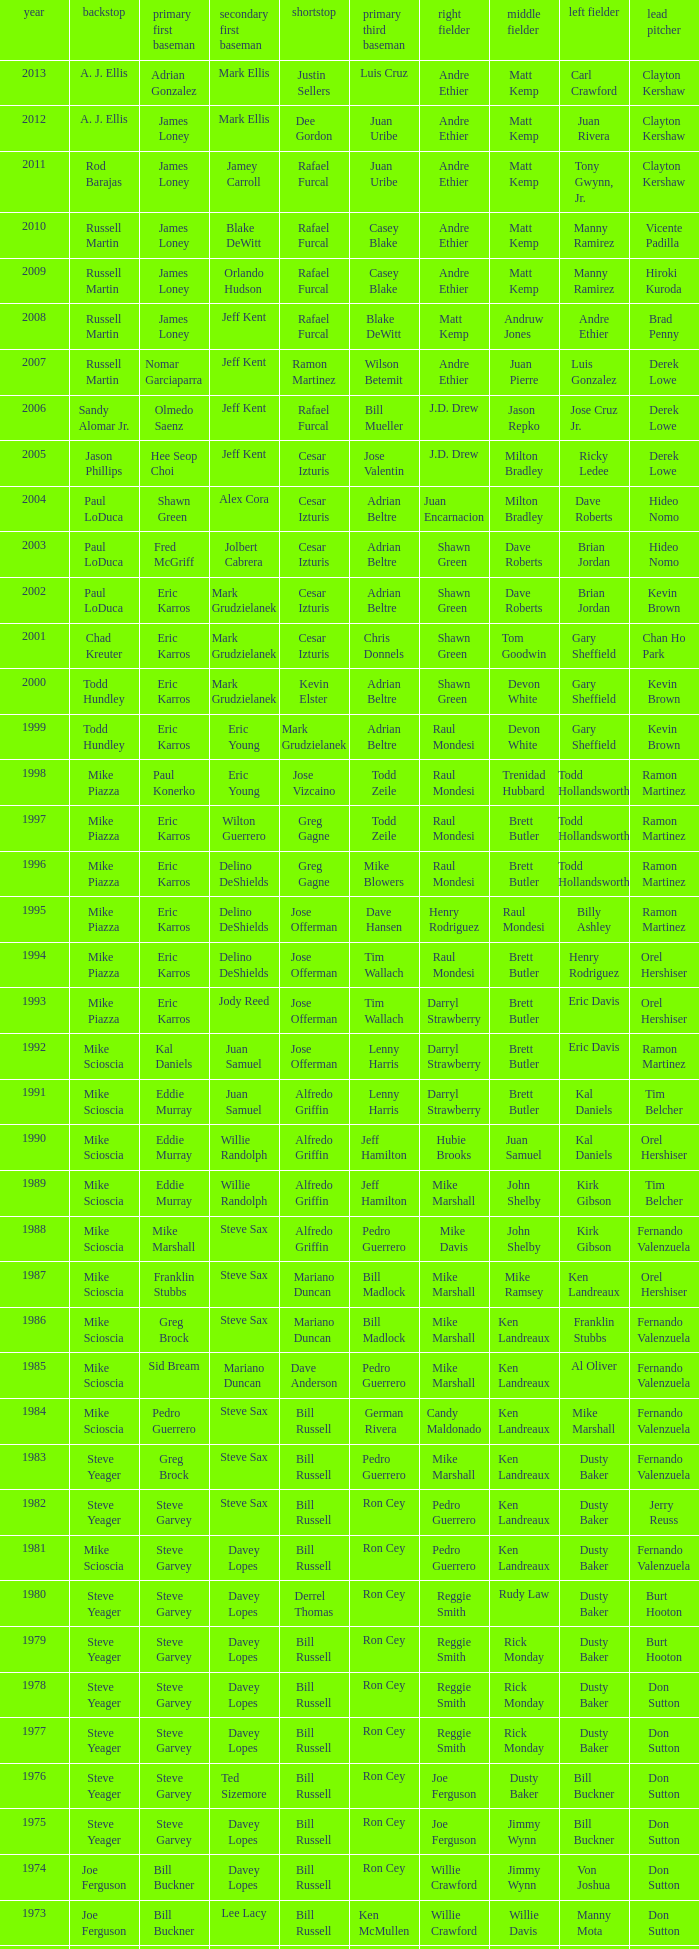Who played SS when paul konerko played 1st base? Jose Vizcaino. Can you parse all the data within this table? {'header': ['year', 'backstop', 'primary first baseman', 'secondary first baseman', 'shortstop', 'primary third baseman', 'right fielder', 'middle fielder', 'left fielder', 'lead pitcher'], 'rows': [['2013', 'A. J. Ellis', 'Adrian Gonzalez', 'Mark Ellis', 'Justin Sellers', 'Luis Cruz', 'Andre Ethier', 'Matt Kemp', 'Carl Crawford', 'Clayton Kershaw'], ['2012', 'A. J. Ellis', 'James Loney', 'Mark Ellis', 'Dee Gordon', 'Juan Uribe', 'Andre Ethier', 'Matt Kemp', 'Juan Rivera', 'Clayton Kershaw'], ['2011', 'Rod Barajas', 'James Loney', 'Jamey Carroll', 'Rafael Furcal', 'Juan Uribe', 'Andre Ethier', 'Matt Kemp', 'Tony Gwynn, Jr.', 'Clayton Kershaw'], ['2010', 'Russell Martin', 'James Loney', 'Blake DeWitt', 'Rafael Furcal', 'Casey Blake', 'Andre Ethier', 'Matt Kemp', 'Manny Ramirez', 'Vicente Padilla'], ['2009', 'Russell Martin', 'James Loney', 'Orlando Hudson', 'Rafael Furcal', 'Casey Blake', 'Andre Ethier', 'Matt Kemp', 'Manny Ramirez', 'Hiroki Kuroda'], ['2008', 'Russell Martin', 'James Loney', 'Jeff Kent', 'Rafael Furcal', 'Blake DeWitt', 'Matt Kemp', 'Andruw Jones', 'Andre Ethier', 'Brad Penny'], ['2007', 'Russell Martin', 'Nomar Garciaparra', 'Jeff Kent', 'Ramon Martinez', 'Wilson Betemit', 'Andre Ethier', 'Juan Pierre', 'Luis Gonzalez', 'Derek Lowe'], ['2006', 'Sandy Alomar Jr.', 'Olmedo Saenz', 'Jeff Kent', 'Rafael Furcal', 'Bill Mueller', 'J.D. Drew', 'Jason Repko', 'Jose Cruz Jr.', 'Derek Lowe'], ['2005', 'Jason Phillips', 'Hee Seop Choi', 'Jeff Kent', 'Cesar Izturis', 'Jose Valentin', 'J.D. Drew', 'Milton Bradley', 'Ricky Ledee', 'Derek Lowe'], ['2004', 'Paul LoDuca', 'Shawn Green', 'Alex Cora', 'Cesar Izturis', 'Adrian Beltre', 'Juan Encarnacion', 'Milton Bradley', 'Dave Roberts', 'Hideo Nomo'], ['2003', 'Paul LoDuca', 'Fred McGriff', 'Jolbert Cabrera', 'Cesar Izturis', 'Adrian Beltre', 'Shawn Green', 'Dave Roberts', 'Brian Jordan', 'Hideo Nomo'], ['2002', 'Paul LoDuca', 'Eric Karros', 'Mark Grudzielanek', 'Cesar Izturis', 'Adrian Beltre', 'Shawn Green', 'Dave Roberts', 'Brian Jordan', 'Kevin Brown'], ['2001', 'Chad Kreuter', 'Eric Karros', 'Mark Grudzielanek', 'Cesar Izturis', 'Chris Donnels', 'Shawn Green', 'Tom Goodwin', 'Gary Sheffield', 'Chan Ho Park'], ['2000', 'Todd Hundley', 'Eric Karros', 'Mark Grudzielanek', 'Kevin Elster', 'Adrian Beltre', 'Shawn Green', 'Devon White', 'Gary Sheffield', 'Kevin Brown'], ['1999', 'Todd Hundley', 'Eric Karros', 'Eric Young', 'Mark Grudzielanek', 'Adrian Beltre', 'Raul Mondesi', 'Devon White', 'Gary Sheffield', 'Kevin Brown'], ['1998', 'Mike Piazza', 'Paul Konerko', 'Eric Young', 'Jose Vizcaino', 'Todd Zeile', 'Raul Mondesi', 'Trenidad Hubbard', 'Todd Hollandsworth', 'Ramon Martinez'], ['1997', 'Mike Piazza', 'Eric Karros', 'Wilton Guerrero', 'Greg Gagne', 'Todd Zeile', 'Raul Mondesi', 'Brett Butler', 'Todd Hollandsworth', 'Ramon Martinez'], ['1996', 'Mike Piazza', 'Eric Karros', 'Delino DeShields', 'Greg Gagne', 'Mike Blowers', 'Raul Mondesi', 'Brett Butler', 'Todd Hollandsworth', 'Ramon Martinez'], ['1995', 'Mike Piazza', 'Eric Karros', 'Delino DeShields', 'Jose Offerman', 'Dave Hansen', 'Henry Rodriguez', 'Raul Mondesi', 'Billy Ashley', 'Ramon Martinez'], ['1994', 'Mike Piazza', 'Eric Karros', 'Delino DeShields', 'Jose Offerman', 'Tim Wallach', 'Raul Mondesi', 'Brett Butler', 'Henry Rodriguez', 'Orel Hershiser'], ['1993', 'Mike Piazza', 'Eric Karros', 'Jody Reed', 'Jose Offerman', 'Tim Wallach', 'Darryl Strawberry', 'Brett Butler', 'Eric Davis', 'Orel Hershiser'], ['1992', 'Mike Scioscia', 'Kal Daniels', 'Juan Samuel', 'Jose Offerman', 'Lenny Harris', 'Darryl Strawberry', 'Brett Butler', 'Eric Davis', 'Ramon Martinez'], ['1991', 'Mike Scioscia', 'Eddie Murray', 'Juan Samuel', 'Alfredo Griffin', 'Lenny Harris', 'Darryl Strawberry', 'Brett Butler', 'Kal Daniels', 'Tim Belcher'], ['1990', 'Mike Scioscia', 'Eddie Murray', 'Willie Randolph', 'Alfredo Griffin', 'Jeff Hamilton', 'Hubie Brooks', 'Juan Samuel', 'Kal Daniels', 'Orel Hershiser'], ['1989', 'Mike Scioscia', 'Eddie Murray', 'Willie Randolph', 'Alfredo Griffin', 'Jeff Hamilton', 'Mike Marshall', 'John Shelby', 'Kirk Gibson', 'Tim Belcher'], ['1988', 'Mike Scioscia', 'Mike Marshall', 'Steve Sax', 'Alfredo Griffin', 'Pedro Guerrero', 'Mike Davis', 'John Shelby', 'Kirk Gibson', 'Fernando Valenzuela'], ['1987', 'Mike Scioscia', 'Franklin Stubbs', 'Steve Sax', 'Mariano Duncan', 'Bill Madlock', 'Mike Marshall', 'Mike Ramsey', 'Ken Landreaux', 'Orel Hershiser'], ['1986', 'Mike Scioscia', 'Greg Brock', 'Steve Sax', 'Mariano Duncan', 'Bill Madlock', 'Mike Marshall', 'Ken Landreaux', 'Franklin Stubbs', 'Fernando Valenzuela'], ['1985', 'Mike Scioscia', 'Sid Bream', 'Mariano Duncan', 'Dave Anderson', 'Pedro Guerrero', 'Mike Marshall', 'Ken Landreaux', 'Al Oliver', 'Fernando Valenzuela'], ['1984', 'Mike Scioscia', 'Pedro Guerrero', 'Steve Sax', 'Bill Russell', 'German Rivera', 'Candy Maldonado', 'Ken Landreaux', 'Mike Marshall', 'Fernando Valenzuela'], ['1983', 'Steve Yeager', 'Greg Brock', 'Steve Sax', 'Bill Russell', 'Pedro Guerrero', 'Mike Marshall', 'Ken Landreaux', 'Dusty Baker', 'Fernando Valenzuela'], ['1982', 'Steve Yeager', 'Steve Garvey', 'Steve Sax', 'Bill Russell', 'Ron Cey', 'Pedro Guerrero', 'Ken Landreaux', 'Dusty Baker', 'Jerry Reuss'], ['1981', 'Mike Scioscia', 'Steve Garvey', 'Davey Lopes', 'Bill Russell', 'Ron Cey', 'Pedro Guerrero', 'Ken Landreaux', 'Dusty Baker', 'Fernando Valenzuela'], ['1980', 'Steve Yeager', 'Steve Garvey', 'Davey Lopes', 'Derrel Thomas', 'Ron Cey', 'Reggie Smith', 'Rudy Law', 'Dusty Baker', 'Burt Hooton'], ['1979', 'Steve Yeager', 'Steve Garvey', 'Davey Lopes', 'Bill Russell', 'Ron Cey', 'Reggie Smith', 'Rick Monday', 'Dusty Baker', 'Burt Hooton'], ['1978', 'Steve Yeager', 'Steve Garvey', 'Davey Lopes', 'Bill Russell', 'Ron Cey', 'Reggie Smith', 'Rick Monday', 'Dusty Baker', 'Don Sutton'], ['1977', 'Steve Yeager', 'Steve Garvey', 'Davey Lopes', 'Bill Russell', 'Ron Cey', 'Reggie Smith', 'Rick Monday', 'Dusty Baker', 'Don Sutton'], ['1976', 'Steve Yeager', 'Steve Garvey', 'Ted Sizemore', 'Bill Russell', 'Ron Cey', 'Joe Ferguson', 'Dusty Baker', 'Bill Buckner', 'Don Sutton'], ['1975', 'Steve Yeager', 'Steve Garvey', 'Davey Lopes', 'Bill Russell', 'Ron Cey', 'Joe Ferguson', 'Jimmy Wynn', 'Bill Buckner', 'Don Sutton'], ['1974', 'Joe Ferguson', 'Bill Buckner', 'Davey Lopes', 'Bill Russell', 'Ron Cey', 'Willie Crawford', 'Jimmy Wynn', 'Von Joshua', 'Don Sutton'], ['1973', 'Joe Ferguson', 'Bill Buckner', 'Lee Lacy', 'Bill Russell', 'Ken McMullen', 'Willie Crawford', 'Willie Davis', 'Manny Mota', 'Don Sutton'], ['1972', 'Duke Sims', 'Bill Buckner', 'Jim Lefebvre', 'Maury Wills', 'Billy Grabarkewitz', 'Frank Robinson', 'Willie Davis', 'Willie Crawford', 'Don Sutton'], ['1971', 'Duke Sims', 'Wes Parker', 'Bill Russell', 'Maury Wills', 'Steve Garvey', 'Bill Buckner', 'Willie Davis', 'Dick Allen', 'Bill Singer'], ['1970', 'Tom Haller', 'Wes Parker', 'Ted Sizemore', 'Maury Wills', 'Steve Garvey', 'Willie Crawford', 'Willie Davis', 'Bill Buckner', 'Claude Osteen'], ['1969', 'Tom Haller', 'Ron Fairly', 'Jim Lefebvre', 'Ted Sizemore', 'Bill Sudakis', 'Len Gabrielson', 'Willie Crawford', 'Andy Kosco', 'Don Drysdale'], ['1968', 'Tom Haller', 'Wes Parker', 'Paul Popovich', 'Zoilo Versalles', 'Bob Bailey', 'Ron Fairly', 'Willie Davis', 'Al Ferrara', 'Claude Osteen'], ['1967', 'Johnny Roseboro', 'Ron Fairly', 'Ron Hunt', 'Gene Michael', 'Jim Lefebvre', 'Lou Johnson', 'Wes Parker', 'Bob Bailey', 'Bob Miller'], ['1966', 'Johnny Roseboro', 'Wes Parker', 'Nate Oliver', 'Maury Wills', 'Jim Lefebvre', 'Ron Fairly', 'Willie Davis', 'Lou Johnson', 'Claude Osteen'], ['1965', 'Johnny Roseboro', 'Wes Parker', 'Jim Lefebvre', 'Maury Wills', 'John Kennedy', 'Ron Fairly', 'Willie Davis', 'Tommy Davis', 'Don Drysdale'], ['1964', 'Johnny Roseboro', 'Ron Fairly', 'Jim Gilliam', 'Maury Wills', 'Johnny Werhas', 'Frank Howard', 'Willie Davis', 'Tommy Davis', 'Sandy Koufax'], ['1963', 'Johnny Roseboro', 'Bill Skowron', 'Nate Oliver', 'Maury Wills', 'Ken McMullen', 'Ron Fairly', 'Willie Davis', 'Tommy Davis', 'Don Drysdale'], ['1962', 'Johnny Roseboro', 'Ron Fairly', 'Jim Gilliam', 'Maury Wills', 'Daryl Spencer', 'Duke Snider', 'Willie Davis', 'Wally Moon', 'Johnny Podres'], ['1961', 'Johnny Roseboro', 'Norm Larker', 'Charlie Neal', 'Maury Wills', 'Tommy Davis', 'Duke Snider', 'Willie Davis', 'Wally Moon', 'Don Drysdale'], ['1960', 'Johnny Roseboro', 'Gil Hodges', 'Charlie Neal', 'Maury Wills', 'Jim Gilliam', 'Duke Snider', 'Don Demeter', 'Wally Moon', 'Don Drysdale'], ['1959', 'Johnny Roseboro', 'Gil Hodges', 'Charlie Neal', 'Don Zimmer', 'Jim Baxes', 'Ron Fairly', 'Duke Snider', 'Wally Moon', 'Don Drysdale']]} 